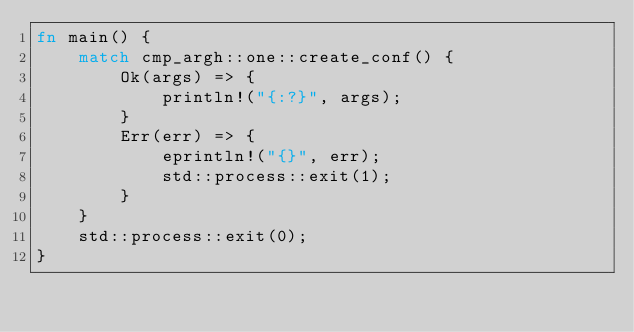Convert code to text. <code><loc_0><loc_0><loc_500><loc_500><_Rust_>fn main() {
    match cmp_argh::one::create_conf() {
        Ok(args) => {
            println!("{:?}", args);
        }
        Err(err) => {
            eprintln!("{}", err);
            std::process::exit(1);
        }
    }
    std::process::exit(0);
}
</code> 